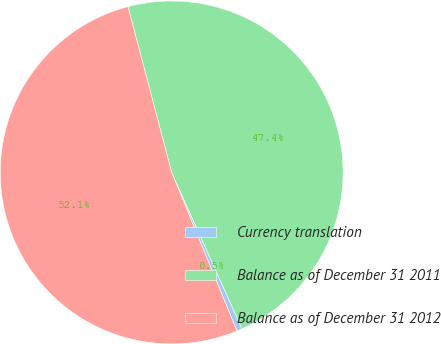Convert chart to OTSL. <chart><loc_0><loc_0><loc_500><loc_500><pie_chart><fcel>Currency translation<fcel>Balance as of December 31 2011<fcel>Balance as of December 31 2012<nl><fcel>0.51%<fcel>47.38%<fcel>52.12%<nl></chart> 